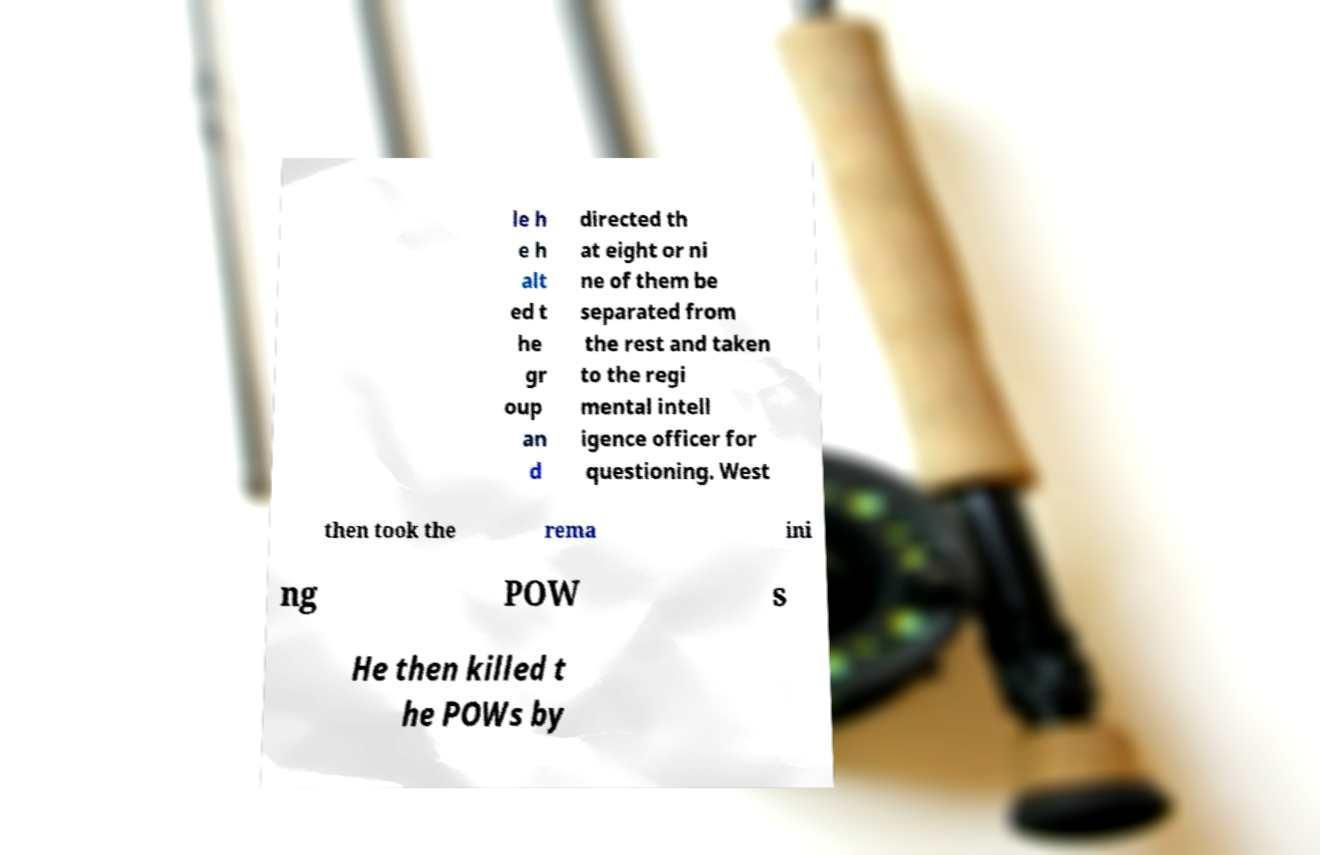Please read and relay the text visible in this image. What does it say? le h e h alt ed t he gr oup an d directed th at eight or ni ne of them be separated from the rest and taken to the regi mental intell igence officer for questioning. West then took the rema ini ng POW s He then killed t he POWs by 